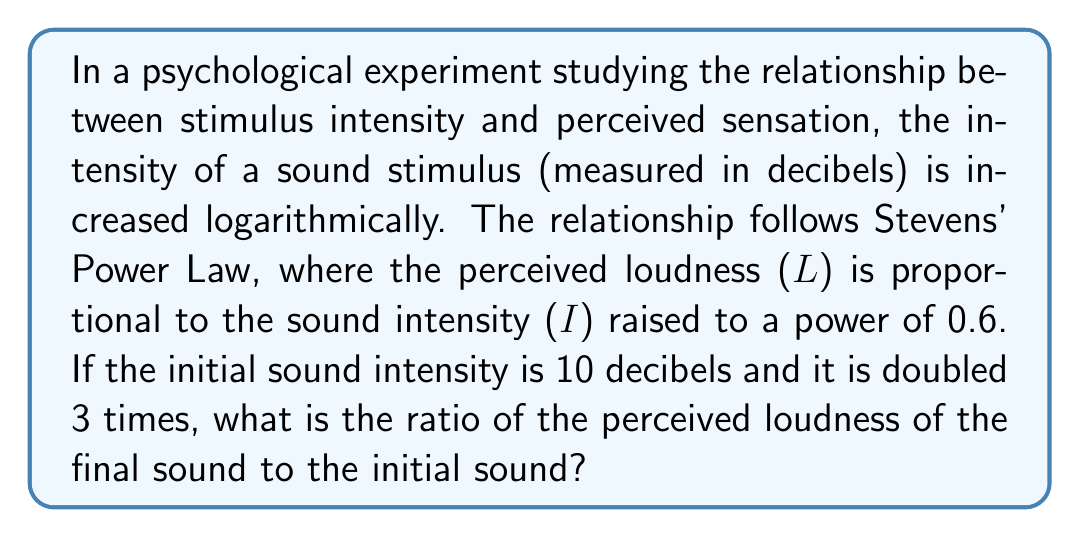Could you help me with this problem? Let's approach this step-by-step:

1) First, let's calculate the final sound intensity after doubling 3 times:
   Initial intensity: $I_0 = 10$ dB
   Final intensity: $I_f = 10 \cdot 2^3 = 80$ dB

2) According to Stevens' Power Law, the perceived loudness (L) is proportional to the sound intensity (I) raised to the power of 0.6:
   $L \propto I^{0.6}$

3) We can write this as an equation:
   $L = k \cdot I^{0.6}$, where k is a constant

4) The ratio of the final perceived loudness to the initial perceived loudness will be:

   $$\frac{L_f}{L_0} = \frac{k \cdot I_f^{0.6}}{k \cdot I_0^{0.6}} = \frac{I_f^{0.6}}{I_0^{0.6}} = \left(\frac{I_f}{I_0}\right)^{0.6}$$

5) We can now substitute our values:

   $$\frac{L_f}{L_0} = \left(\frac{80}{10}\right)^{0.6} = 8^{0.6}$$

6) Calculate the final result:
   $8^{0.6} \approx 3.0314$

Therefore, the perceived loudness of the final sound is approximately 3.0314 times the perceived loudness of the initial sound.
Answer: $3.0314:1$ 